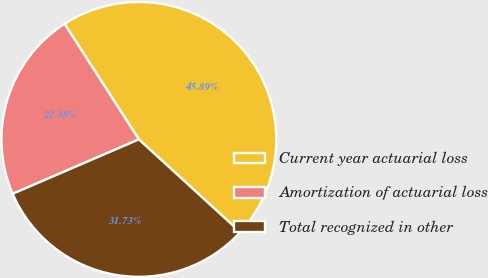Convert chart to OTSL. <chart><loc_0><loc_0><loc_500><loc_500><pie_chart><fcel>Current year actuarial loss<fcel>Amortization of actuarial loss<fcel>Total recognized in other<nl><fcel>45.89%<fcel>22.38%<fcel>31.73%<nl></chart> 